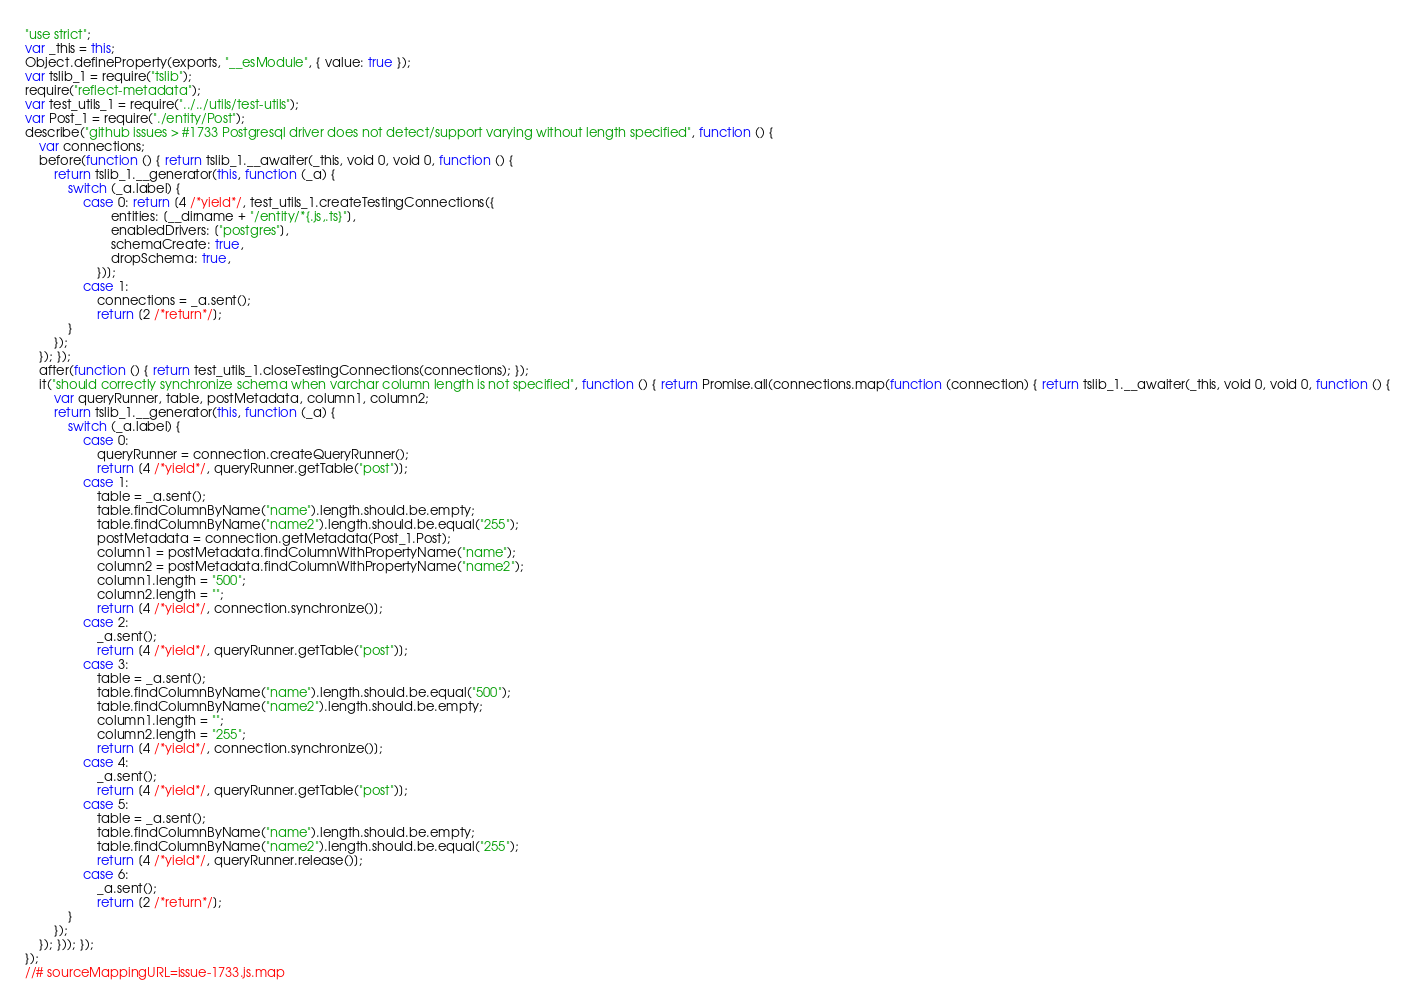<code> <loc_0><loc_0><loc_500><loc_500><_JavaScript_>"use strict";
var _this = this;
Object.defineProperty(exports, "__esModule", { value: true });
var tslib_1 = require("tslib");
require("reflect-metadata");
var test_utils_1 = require("../../utils/test-utils");
var Post_1 = require("./entity/Post");
describe("github issues > #1733 Postgresql driver does not detect/support varying without length specified", function () {
    var connections;
    before(function () { return tslib_1.__awaiter(_this, void 0, void 0, function () {
        return tslib_1.__generator(this, function (_a) {
            switch (_a.label) {
                case 0: return [4 /*yield*/, test_utils_1.createTestingConnections({
                        entities: [__dirname + "/entity/*{.js,.ts}"],
                        enabledDrivers: ["postgres"],
                        schemaCreate: true,
                        dropSchema: true,
                    })];
                case 1:
                    connections = _a.sent();
                    return [2 /*return*/];
            }
        });
    }); });
    after(function () { return test_utils_1.closeTestingConnections(connections); });
    it("should correctly synchronize schema when varchar column length is not specified", function () { return Promise.all(connections.map(function (connection) { return tslib_1.__awaiter(_this, void 0, void 0, function () {
        var queryRunner, table, postMetadata, column1, column2;
        return tslib_1.__generator(this, function (_a) {
            switch (_a.label) {
                case 0:
                    queryRunner = connection.createQueryRunner();
                    return [4 /*yield*/, queryRunner.getTable("post")];
                case 1:
                    table = _a.sent();
                    table.findColumnByName("name").length.should.be.empty;
                    table.findColumnByName("name2").length.should.be.equal("255");
                    postMetadata = connection.getMetadata(Post_1.Post);
                    column1 = postMetadata.findColumnWithPropertyName("name");
                    column2 = postMetadata.findColumnWithPropertyName("name2");
                    column1.length = "500";
                    column2.length = "";
                    return [4 /*yield*/, connection.synchronize()];
                case 2:
                    _a.sent();
                    return [4 /*yield*/, queryRunner.getTable("post")];
                case 3:
                    table = _a.sent();
                    table.findColumnByName("name").length.should.be.equal("500");
                    table.findColumnByName("name2").length.should.be.empty;
                    column1.length = "";
                    column2.length = "255";
                    return [4 /*yield*/, connection.synchronize()];
                case 4:
                    _a.sent();
                    return [4 /*yield*/, queryRunner.getTable("post")];
                case 5:
                    table = _a.sent();
                    table.findColumnByName("name").length.should.be.empty;
                    table.findColumnByName("name2").length.should.be.equal("255");
                    return [4 /*yield*/, queryRunner.release()];
                case 6:
                    _a.sent();
                    return [2 /*return*/];
            }
        });
    }); })); });
});
//# sourceMappingURL=issue-1733.js.map</code> 